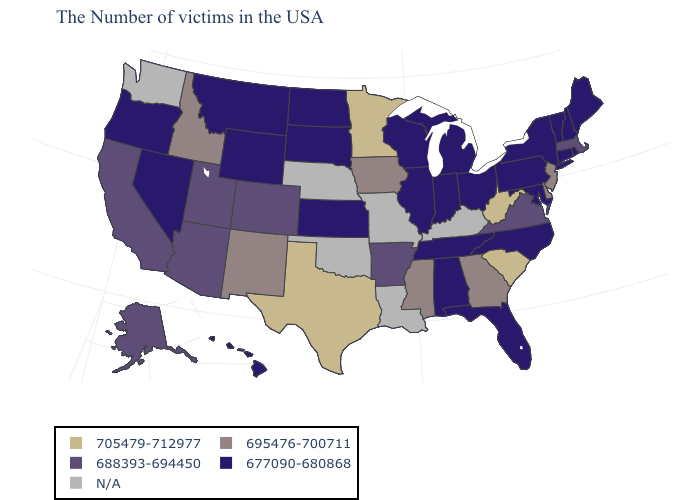Name the states that have a value in the range 677090-680868?
Write a very short answer. Maine, Rhode Island, New Hampshire, Vermont, Connecticut, New York, Maryland, Pennsylvania, North Carolina, Ohio, Florida, Michigan, Indiana, Alabama, Tennessee, Wisconsin, Illinois, Kansas, South Dakota, North Dakota, Wyoming, Montana, Nevada, Oregon, Hawaii. What is the value of Alaska?
Keep it brief. 688393-694450. Which states hav the highest value in the West?
Keep it brief. New Mexico, Idaho. What is the highest value in the West ?
Keep it brief. 695476-700711. Name the states that have a value in the range 688393-694450?
Quick response, please. Massachusetts, Virginia, Arkansas, Colorado, Utah, Arizona, California, Alaska. What is the value of Oklahoma?
Quick response, please. N/A. What is the highest value in the USA?
Write a very short answer. 705479-712977. Name the states that have a value in the range N/A?
Answer briefly. Kentucky, Louisiana, Missouri, Nebraska, Oklahoma, Washington. What is the value of North Carolina?
Answer briefly. 677090-680868. What is the lowest value in the USA?
Keep it brief. 677090-680868. What is the value of Oklahoma?
Answer briefly. N/A. What is the value of Hawaii?
Short answer required. 677090-680868. Name the states that have a value in the range 688393-694450?
Keep it brief. Massachusetts, Virginia, Arkansas, Colorado, Utah, Arizona, California, Alaska. 